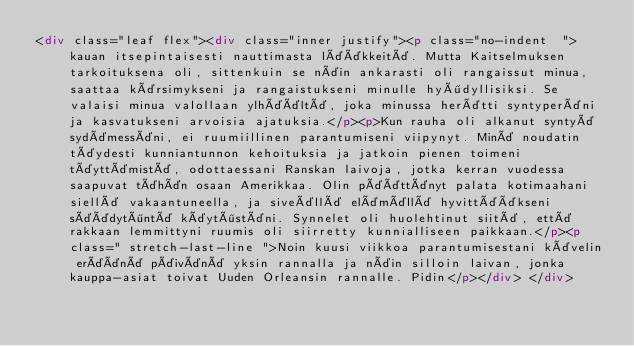<code> <loc_0><loc_0><loc_500><loc_500><_HTML_><div class="leaf flex"><div class="inner justify"><p class="no-indent  ">kauan itsepintaisesti nauttimasta lääkkeitä. Mutta Kaitselmuksen tarkoituksena oli, sittenkuin se näin ankarasti oli rangaissut minua, saattaa kärsimykseni ja rangaistukseni minulle hyödyllisiksi. Se valaisi minua valollaan ylhäältä, joka minussa herätti syntyperäni ja kasvatukseni arvoisia ajatuksia.</p><p>Kun rauha oli alkanut syntyä sydämessäni, ei ruumiillinen parantumiseni viipynyt. Minä noudatin täydesti kunniantunnon kehoituksia ja jatkoin pienen toimeni täyttämistä, odottaessani Ranskan laivoja, jotka kerran vuodessa saapuvat tähän osaan Amerikkaa. Olin päättänyt palata kotimaahani siellä vakaantuneella, ja siveällä elämällä hyvittääkseni säädytöntä käytöstäni. Synnelet oli huolehtinut siitä, että rakkaan lemmittyni ruumis oli siirretty kunnialliseen paikkaan.</p><p class=" stretch-last-line ">Noin kuusi viikkoa parantumisestani kävelin eräänä päivänä yksin rannalla ja näin silloin laivan, jonka kauppa-asiat toivat Uuden Orleansin rannalle. Pidin</p></div> </div></code> 